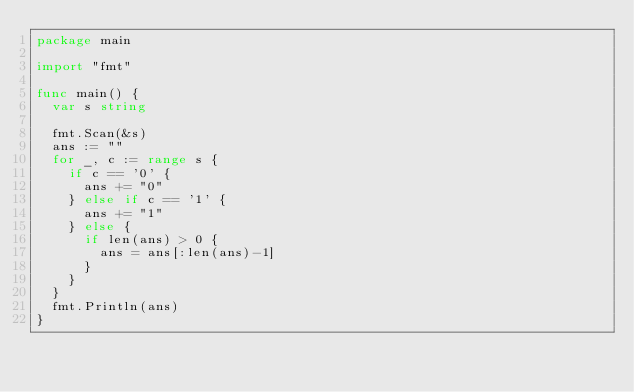Convert code to text. <code><loc_0><loc_0><loc_500><loc_500><_Go_>package main

import "fmt"

func main() {
	var s string

	fmt.Scan(&s)
	ans := ""
	for _, c := range s {
		if c == '0' {
			ans += "0"
		} else if c == '1' {
			ans += "1"
		} else {
			if len(ans) > 0 {
				ans = ans[:len(ans)-1]
			}
		}
	}
	fmt.Println(ans)
}
</code> 